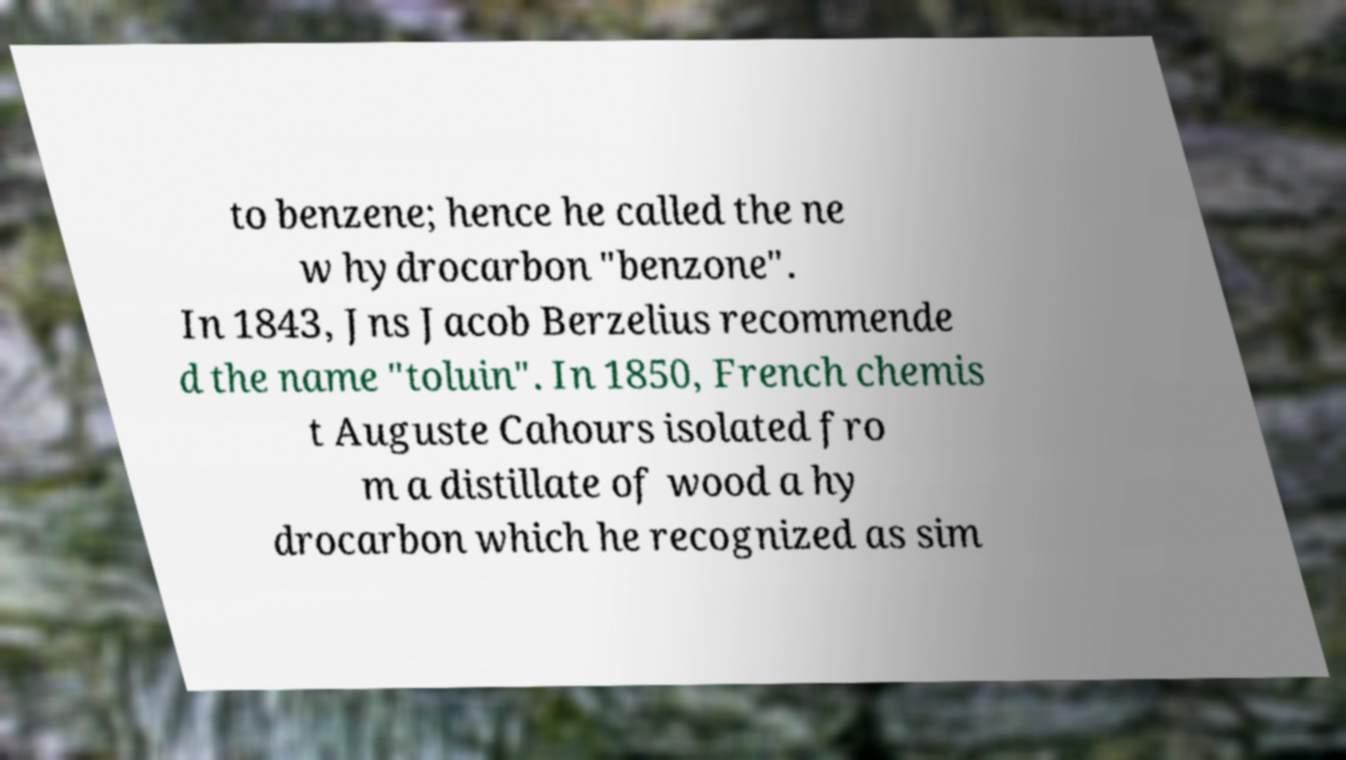Please read and relay the text visible in this image. What does it say? to benzene; hence he called the ne w hydrocarbon "benzone". In 1843, Jns Jacob Berzelius recommende d the name "toluin". In 1850, French chemis t Auguste Cahours isolated fro m a distillate of wood a hy drocarbon which he recognized as sim 